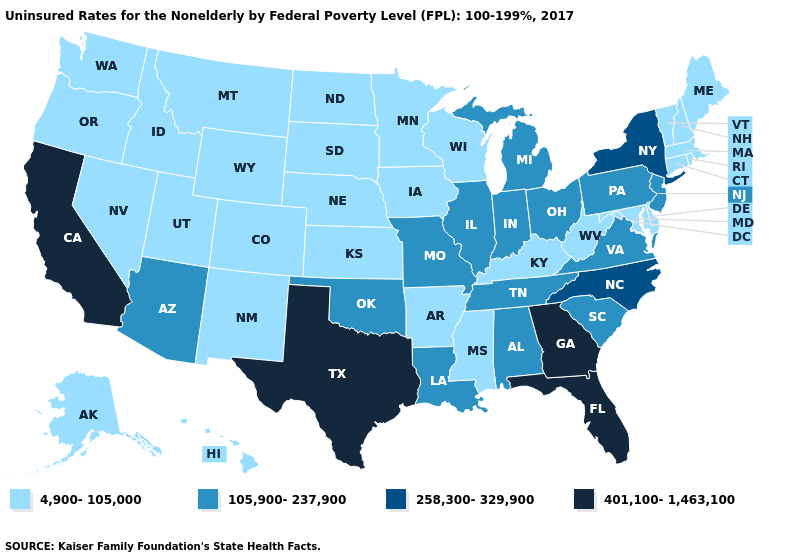Name the states that have a value in the range 105,900-237,900?
Answer briefly. Alabama, Arizona, Illinois, Indiana, Louisiana, Michigan, Missouri, New Jersey, Ohio, Oklahoma, Pennsylvania, South Carolina, Tennessee, Virginia. What is the lowest value in the Northeast?
Answer briefly. 4,900-105,000. Does Arizona have the lowest value in the USA?
Short answer required. No. What is the value of Alabama?
Write a very short answer. 105,900-237,900. What is the highest value in the West ?
Quick response, please. 401,100-1,463,100. What is the lowest value in the MidWest?
Answer briefly. 4,900-105,000. Which states hav the highest value in the MidWest?
Short answer required. Illinois, Indiana, Michigan, Missouri, Ohio. Does Illinois have the highest value in the MidWest?
Short answer required. Yes. Name the states that have a value in the range 4,900-105,000?
Concise answer only. Alaska, Arkansas, Colorado, Connecticut, Delaware, Hawaii, Idaho, Iowa, Kansas, Kentucky, Maine, Maryland, Massachusetts, Minnesota, Mississippi, Montana, Nebraska, Nevada, New Hampshire, New Mexico, North Dakota, Oregon, Rhode Island, South Dakota, Utah, Vermont, Washington, West Virginia, Wisconsin, Wyoming. What is the highest value in the USA?
Concise answer only. 401,100-1,463,100. What is the value of North Dakota?
Be succinct. 4,900-105,000. What is the value of Mississippi?
Concise answer only. 4,900-105,000. Does Maryland have the lowest value in the USA?
Give a very brief answer. Yes. Name the states that have a value in the range 105,900-237,900?
Write a very short answer. Alabama, Arizona, Illinois, Indiana, Louisiana, Michigan, Missouri, New Jersey, Ohio, Oklahoma, Pennsylvania, South Carolina, Tennessee, Virginia. Which states have the highest value in the USA?
Be succinct. California, Florida, Georgia, Texas. 